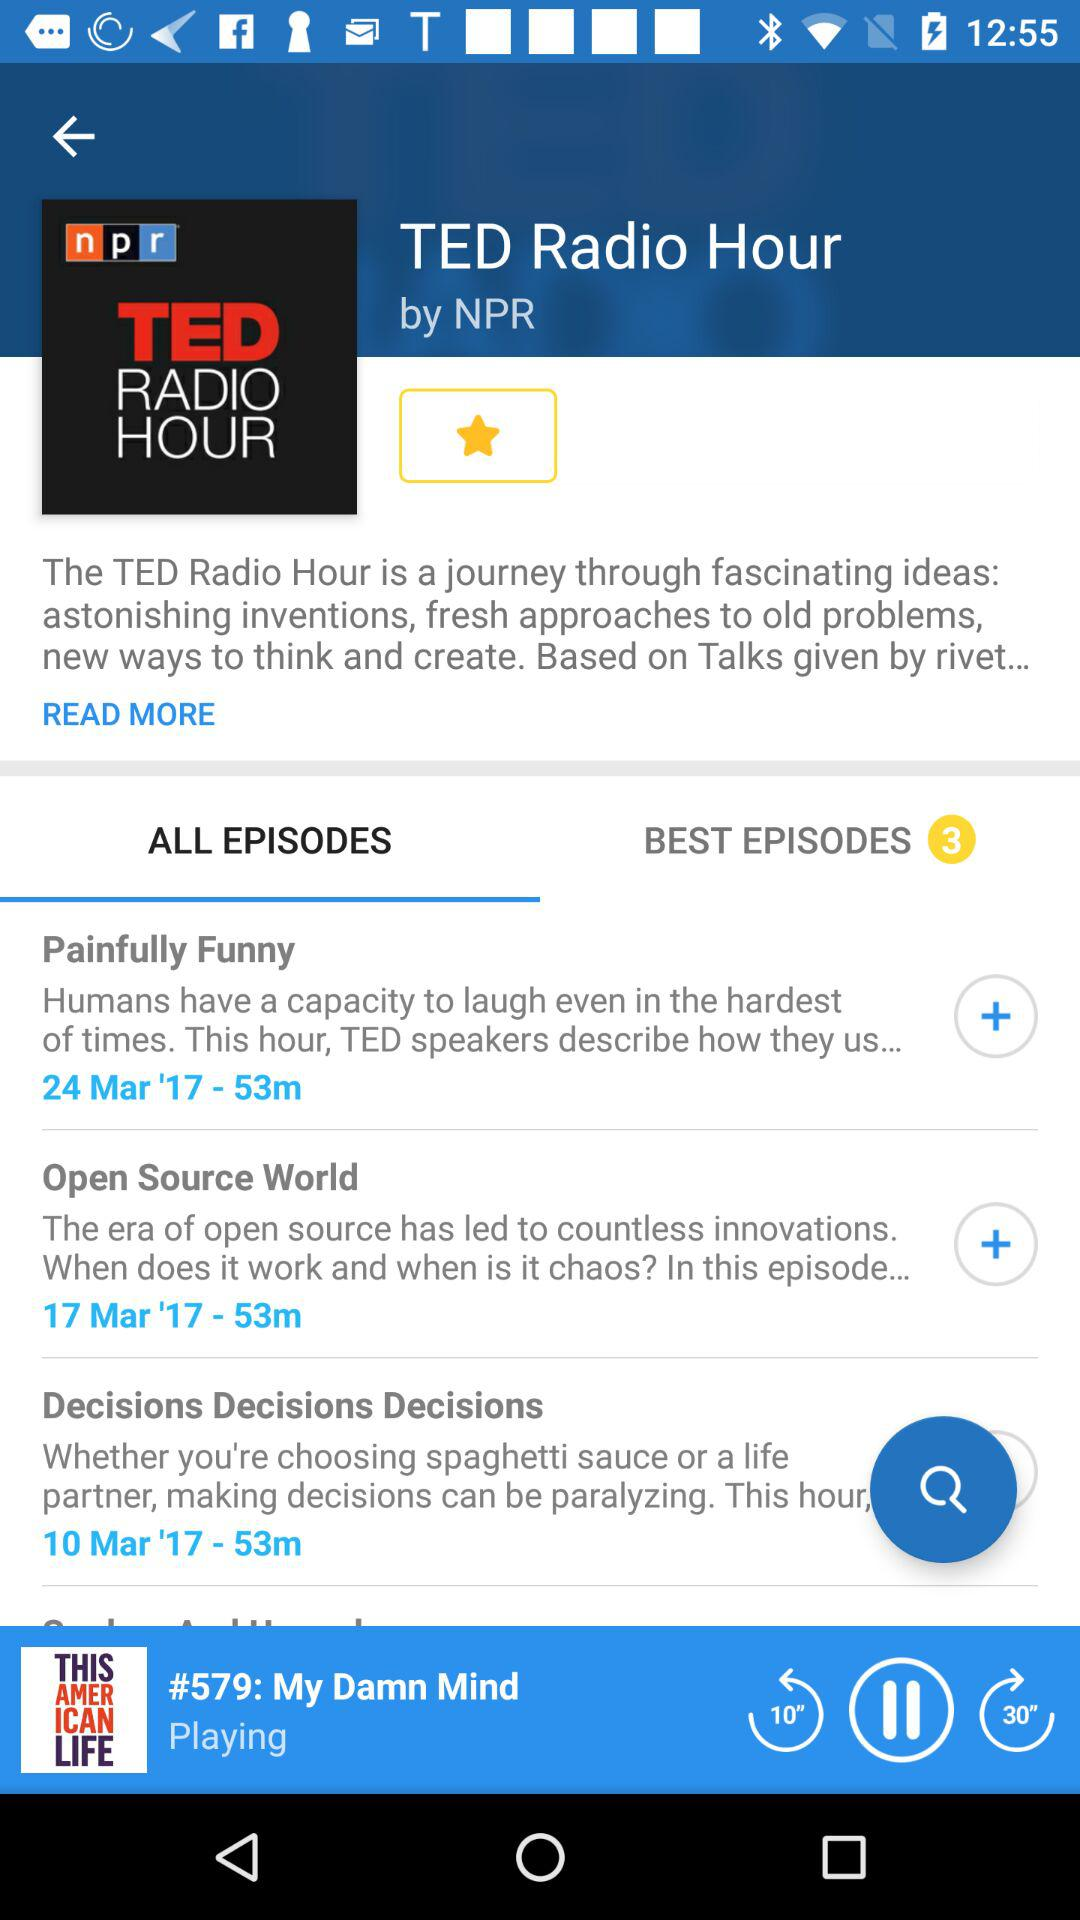What is the number of the best episodes? The number of the best episodes is 3. 